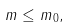<formula> <loc_0><loc_0><loc_500><loc_500>m \leq m _ { 0 } ,</formula> 